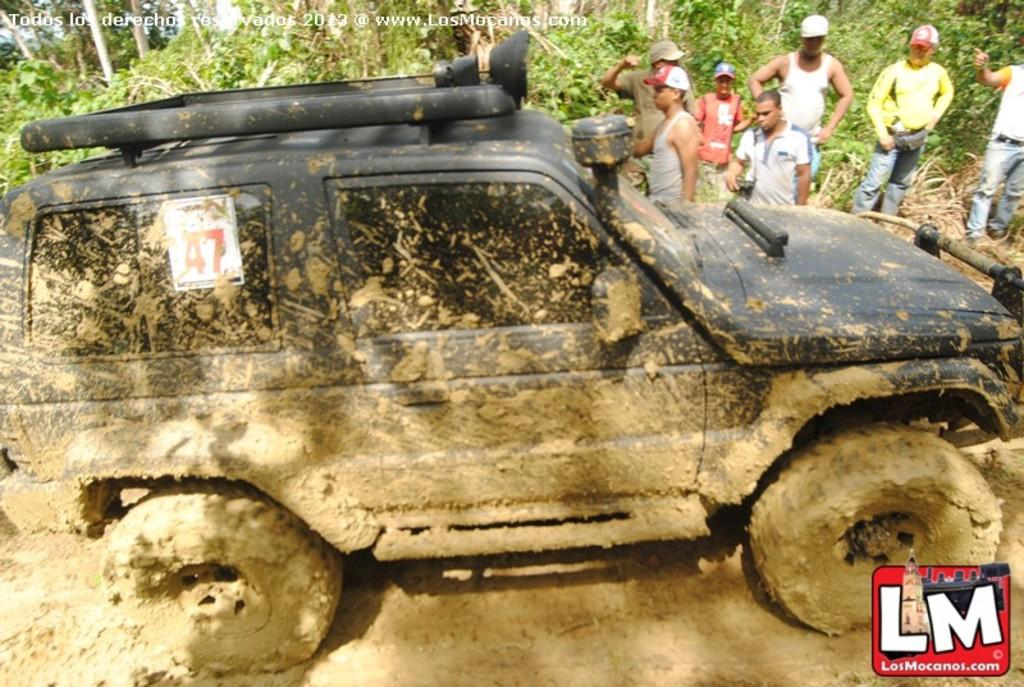What is the main subject in the center of the image? There is a car in the center of the image. Where is the logo located in the image? The logo is in the bottom right side of the image. What can be seen in the background of the image? There are trees and people visible in the background of the image. Can you see any snails crawling on the car in the image? There are no snails visible on the car in the image. Are there any beds present in the image? There are no beds visible in the image. 